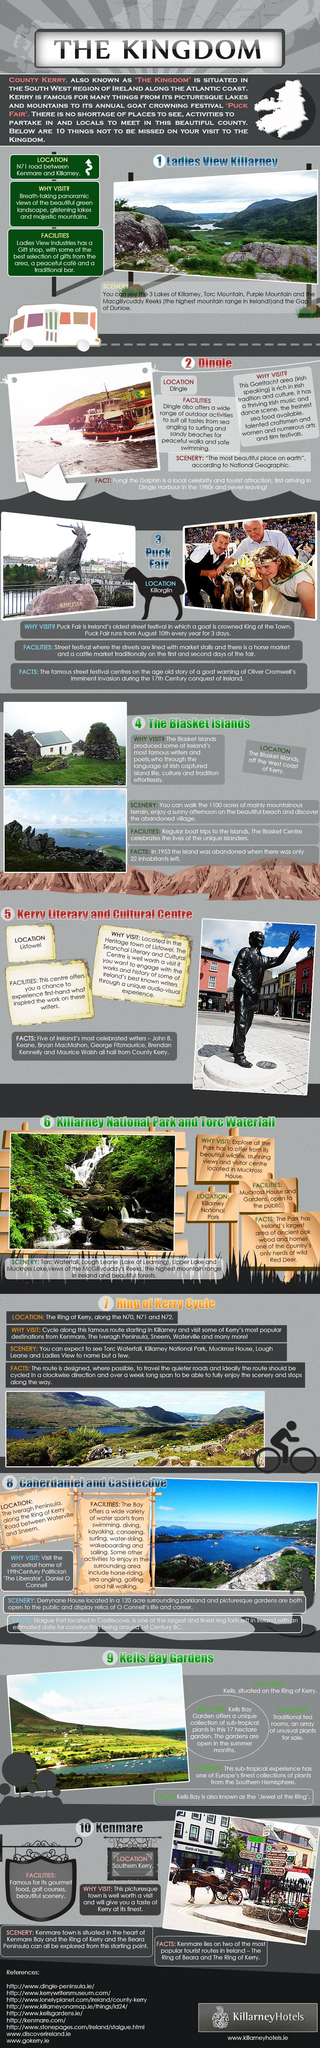Mention a couple of crucial points in this snapshot. The Kerry Literary and Cultural Centre is located in Listowel. Fungi the Dolphin, who has not left Dingle Harbour since the 1980s, is the only known individual to have done so. From Ladies View in Killarney, the highest mountain range in Ireland can be seen. The Puck Fair is held in Killorglin. Dingle is located in a Gaeltacht area. 